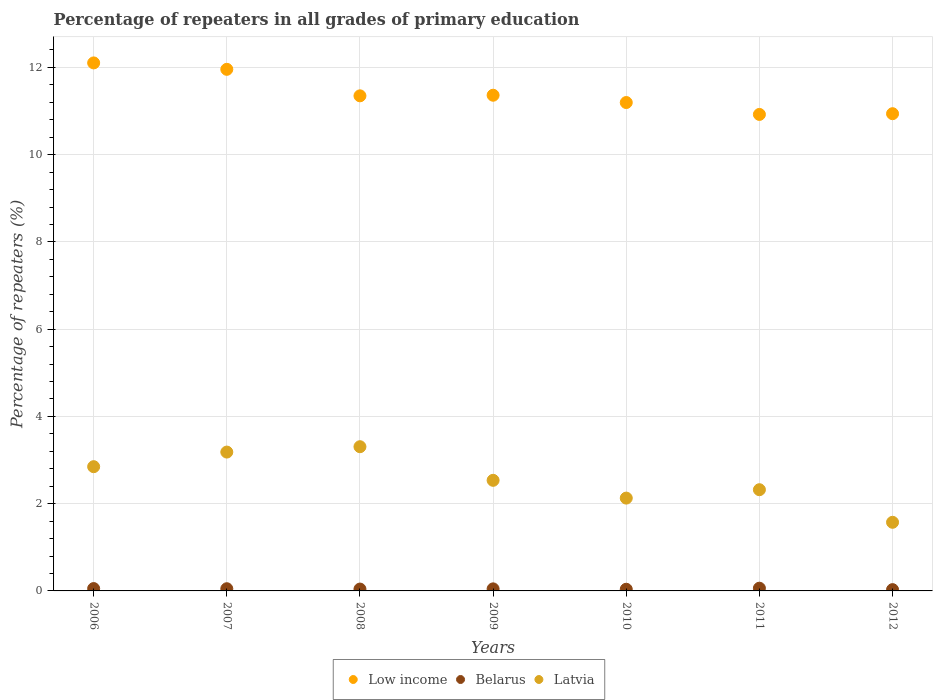Is the number of dotlines equal to the number of legend labels?
Keep it short and to the point. Yes. What is the percentage of repeaters in Belarus in 2011?
Provide a succinct answer. 0.06. Across all years, what is the maximum percentage of repeaters in Latvia?
Provide a succinct answer. 3.31. Across all years, what is the minimum percentage of repeaters in Latvia?
Give a very brief answer. 1.57. In which year was the percentage of repeaters in Low income maximum?
Your answer should be compact. 2006. What is the total percentage of repeaters in Low income in the graph?
Your response must be concise. 79.83. What is the difference between the percentage of repeaters in Low income in 2008 and that in 2011?
Make the answer very short. 0.43. What is the difference between the percentage of repeaters in Belarus in 2012 and the percentage of repeaters in Low income in 2010?
Offer a terse response. -11.17. What is the average percentage of repeaters in Low income per year?
Provide a short and direct response. 11.4. In the year 2007, what is the difference between the percentage of repeaters in Latvia and percentage of repeaters in Low income?
Your answer should be very brief. -8.77. What is the ratio of the percentage of repeaters in Low income in 2006 to that in 2008?
Your answer should be compact. 1.07. What is the difference between the highest and the second highest percentage of repeaters in Low income?
Provide a succinct answer. 0.15. What is the difference between the highest and the lowest percentage of repeaters in Latvia?
Ensure brevity in your answer.  1.73. Is it the case that in every year, the sum of the percentage of repeaters in Low income and percentage of repeaters in Belarus  is greater than the percentage of repeaters in Latvia?
Provide a short and direct response. Yes. Does the percentage of repeaters in Latvia monotonically increase over the years?
Make the answer very short. No. How many dotlines are there?
Ensure brevity in your answer.  3. How many years are there in the graph?
Your answer should be compact. 7. What is the difference between two consecutive major ticks on the Y-axis?
Ensure brevity in your answer.  2. Are the values on the major ticks of Y-axis written in scientific E-notation?
Provide a succinct answer. No. Does the graph contain any zero values?
Your answer should be compact. No. Does the graph contain grids?
Give a very brief answer. Yes. Where does the legend appear in the graph?
Your response must be concise. Bottom center. How many legend labels are there?
Provide a succinct answer. 3. What is the title of the graph?
Your answer should be compact. Percentage of repeaters in all grades of primary education. What is the label or title of the X-axis?
Offer a very short reply. Years. What is the label or title of the Y-axis?
Offer a terse response. Percentage of repeaters (%). What is the Percentage of repeaters (%) of Low income in 2006?
Give a very brief answer. 12.1. What is the Percentage of repeaters (%) in Belarus in 2006?
Provide a short and direct response. 0.05. What is the Percentage of repeaters (%) of Latvia in 2006?
Ensure brevity in your answer.  2.85. What is the Percentage of repeaters (%) in Low income in 2007?
Keep it short and to the point. 11.96. What is the Percentage of repeaters (%) in Belarus in 2007?
Give a very brief answer. 0.05. What is the Percentage of repeaters (%) in Latvia in 2007?
Provide a succinct answer. 3.18. What is the Percentage of repeaters (%) in Low income in 2008?
Offer a very short reply. 11.35. What is the Percentage of repeaters (%) in Belarus in 2008?
Make the answer very short. 0.04. What is the Percentage of repeaters (%) of Latvia in 2008?
Give a very brief answer. 3.31. What is the Percentage of repeaters (%) in Low income in 2009?
Your answer should be very brief. 11.36. What is the Percentage of repeaters (%) in Belarus in 2009?
Offer a terse response. 0.05. What is the Percentage of repeaters (%) of Latvia in 2009?
Your response must be concise. 2.54. What is the Percentage of repeaters (%) in Low income in 2010?
Your answer should be very brief. 11.19. What is the Percentage of repeaters (%) of Belarus in 2010?
Ensure brevity in your answer.  0.04. What is the Percentage of repeaters (%) of Latvia in 2010?
Provide a succinct answer. 2.13. What is the Percentage of repeaters (%) in Low income in 2011?
Provide a short and direct response. 10.92. What is the Percentage of repeaters (%) in Belarus in 2011?
Your answer should be compact. 0.06. What is the Percentage of repeaters (%) of Latvia in 2011?
Offer a very short reply. 2.32. What is the Percentage of repeaters (%) in Low income in 2012?
Provide a succinct answer. 10.94. What is the Percentage of repeaters (%) in Belarus in 2012?
Provide a short and direct response. 0.03. What is the Percentage of repeaters (%) in Latvia in 2012?
Provide a succinct answer. 1.57. Across all years, what is the maximum Percentage of repeaters (%) of Low income?
Keep it short and to the point. 12.1. Across all years, what is the maximum Percentage of repeaters (%) in Belarus?
Make the answer very short. 0.06. Across all years, what is the maximum Percentage of repeaters (%) of Latvia?
Offer a very short reply. 3.31. Across all years, what is the minimum Percentage of repeaters (%) in Low income?
Give a very brief answer. 10.92. Across all years, what is the minimum Percentage of repeaters (%) in Belarus?
Offer a very short reply. 0.03. Across all years, what is the minimum Percentage of repeaters (%) in Latvia?
Your answer should be compact. 1.57. What is the total Percentage of repeaters (%) in Low income in the graph?
Give a very brief answer. 79.83. What is the total Percentage of repeaters (%) in Belarus in the graph?
Make the answer very short. 0.32. What is the total Percentage of repeaters (%) in Latvia in the graph?
Give a very brief answer. 17.89. What is the difference between the Percentage of repeaters (%) in Low income in 2006 and that in 2007?
Keep it short and to the point. 0.15. What is the difference between the Percentage of repeaters (%) in Belarus in 2006 and that in 2007?
Offer a very short reply. 0. What is the difference between the Percentage of repeaters (%) of Latvia in 2006 and that in 2007?
Keep it short and to the point. -0.33. What is the difference between the Percentage of repeaters (%) of Low income in 2006 and that in 2008?
Your answer should be compact. 0.75. What is the difference between the Percentage of repeaters (%) of Belarus in 2006 and that in 2008?
Offer a very short reply. 0.01. What is the difference between the Percentage of repeaters (%) in Latvia in 2006 and that in 2008?
Ensure brevity in your answer.  -0.46. What is the difference between the Percentage of repeaters (%) in Low income in 2006 and that in 2009?
Make the answer very short. 0.74. What is the difference between the Percentage of repeaters (%) of Belarus in 2006 and that in 2009?
Offer a very short reply. 0.01. What is the difference between the Percentage of repeaters (%) of Latvia in 2006 and that in 2009?
Make the answer very short. 0.31. What is the difference between the Percentage of repeaters (%) in Low income in 2006 and that in 2010?
Your answer should be very brief. 0.91. What is the difference between the Percentage of repeaters (%) of Belarus in 2006 and that in 2010?
Ensure brevity in your answer.  0.02. What is the difference between the Percentage of repeaters (%) of Latvia in 2006 and that in 2010?
Make the answer very short. 0.72. What is the difference between the Percentage of repeaters (%) in Low income in 2006 and that in 2011?
Provide a short and direct response. 1.18. What is the difference between the Percentage of repeaters (%) of Belarus in 2006 and that in 2011?
Your answer should be very brief. -0.01. What is the difference between the Percentage of repeaters (%) in Latvia in 2006 and that in 2011?
Your answer should be very brief. 0.53. What is the difference between the Percentage of repeaters (%) of Low income in 2006 and that in 2012?
Make the answer very short. 1.16. What is the difference between the Percentage of repeaters (%) in Belarus in 2006 and that in 2012?
Provide a succinct answer. 0.02. What is the difference between the Percentage of repeaters (%) in Latvia in 2006 and that in 2012?
Ensure brevity in your answer.  1.27. What is the difference between the Percentage of repeaters (%) in Low income in 2007 and that in 2008?
Offer a terse response. 0.61. What is the difference between the Percentage of repeaters (%) in Belarus in 2007 and that in 2008?
Make the answer very short. 0.01. What is the difference between the Percentage of repeaters (%) of Latvia in 2007 and that in 2008?
Make the answer very short. -0.12. What is the difference between the Percentage of repeaters (%) of Low income in 2007 and that in 2009?
Your answer should be compact. 0.59. What is the difference between the Percentage of repeaters (%) in Belarus in 2007 and that in 2009?
Your answer should be very brief. 0. What is the difference between the Percentage of repeaters (%) in Latvia in 2007 and that in 2009?
Provide a succinct answer. 0.65. What is the difference between the Percentage of repeaters (%) of Low income in 2007 and that in 2010?
Your answer should be compact. 0.76. What is the difference between the Percentage of repeaters (%) in Belarus in 2007 and that in 2010?
Make the answer very short. 0.01. What is the difference between the Percentage of repeaters (%) in Latvia in 2007 and that in 2010?
Ensure brevity in your answer.  1.05. What is the difference between the Percentage of repeaters (%) in Low income in 2007 and that in 2011?
Your answer should be very brief. 1.03. What is the difference between the Percentage of repeaters (%) of Belarus in 2007 and that in 2011?
Offer a very short reply. -0.01. What is the difference between the Percentage of repeaters (%) in Latvia in 2007 and that in 2011?
Offer a very short reply. 0.86. What is the difference between the Percentage of repeaters (%) in Low income in 2007 and that in 2012?
Your answer should be very brief. 1.02. What is the difference between the Percentage of repeaters (%) of Belarus in 2007 and that in 2012?
Your answer should be compact. 0.02. What is the difference between the Percentage of repeaters (%) of Latvia in 2007 and that in 2012?
Your answer should be very brief. 1.61. What is the difference between the Percentage of repeaters (%) in Low income in 2008 and that in 2009?
Your response must be concise. -0.01. What is the difference between the Percentage of repeaters (%) in Belarus in 2008 and that in 2009?
Give a very brief answer. -0. What is the difference between the Percentage of repeaters (%) in Latvia in 2008 and that in 2009?
Keep it short and to the point. 0.77. What is the difference between the Percentage of repeaters (%) of Low income in 2008 and that in 2010?
Offer a very short reply. 0.15. What is the difference between the Percentage of repeaters (%) in Belarus in 2008 and that in 2010?
Your answer should be very brief. 0. What is the difference between the Percentage of repeaters (%) of Latvia in 2008 and that in 2010?
Provide a succinct answer. 1.18. What is the difference between the Percentage of repeaters (%) of Low income in 2008 and that in 2011?
Keep it short and to the point. 0.43. What is the difference between the Percentage of repeaters (%) in Belarus in 2008 and that in 2011?
Your response must be concise. -0.02. What is the difference between the Percentage of repeaters (%) in Latvia in 2008 and that in 2011?
Keep it short and to the point. 0.99. What is the difference between the Percentage of repeaters (%) of Low income in 2008 and that in 2012?
Your answer should be compact. 0.41. What is the difference between the Percentage of repeaters (%) in Belarus in 2008 and that in 2012?
Your answer should be compact. 0.01. What is the difference between the Percentage of repeaters (%) of Latvia in 2008 and that in 2012?
Your response must be concise. 1.73. What is the difference between the Percentage of repeaters (%) in Low income in 2009 and that in 2010?
Keep it short and to the point. 0.17. What is the difference between the Percentage of repeaters (%) in Belarus in 2009 and that in 2010?
Offer a terse response. 0.01. What is the difference between the Percentage of repeaters (%) in Latvia in 2009 and that in 2010?
Offer a terse response. 0.41. What is the difference between the Percentage of repeaters (%) in Low income in 2009 and that in 2011?
Keep it short and to the point. 0.44. What is the difference between the Percentage of repeaters (%) of Belarus in 2009 and that in 2011?
Keep it short and to the point. -0.02. What is the difference between the Percentage of repeaters (%) in Latvia in 2009 and that in 2011?
Offer a very short reply. 0.22. What is the difference between the Percentage of repeaters (%) in Low income in 2009 and that in 2012?
Offer a very short reply. 0.42. What is the difference between the Percentage of repeaters (%) in Belarus in 2009 and that in 2012?
Keep it short and to the point. 0.02. What is the difference between the Percentage of repeaters (%) in Latvia in 2009 and that in 2012?
Your answer should be very brief. 0.96. What is the difference between the Percentage of repeaters (%) in Low income in 2010 and that in 2011?
Offer a terse response. 0.27. What is the difference between the Percentage of repeaters (%) in Belarus in 2010 and that in 2011?
Keep it short and to the point. -0.02. What is the difference between the Percentage of repeaters (%) of Latvia in 2010 and that in 2011?
Offer a very short reply. -0.19. What is the difference between the Percentage of repeaters (%) of Low income in 2010 and that in 2012?
Give a very brief answer. 0.26. What is the difference between the Percentage of repeaters (%) in Belarus in 2010 and that in 2012?
Provide a succinct answer. 0.01. What is the difference between the Percentage of repeaters (%) in Latvia in 2010 and that in 2012?
Your answer should be very brief. 0.55. What is the difference between the Percentage of repeaters (%) in Low income in 2011 and that in 2012?
Your answer should be very brief. -0.02. What is the difference between the Percentage of repeaters (%) of Belarus in 2011 and that in 2012?
Make the answer very short. 0.03. What is the difference between the Percentage of repeaters (%) of Latvia in 2011 and that in 2012?
Provide a succinct answer. 0.75. What is the difference between the Percentage of repeaters (%) in Low income in 2006 and the Percentage of repeaters (%) in Belarus in 2007?
Provide a short and direct response. 12.05. What is the difference between the Percentage of repeaters (%) of Low income in 2006 and the Percentage of repeaters (%) of Latvia in 2007?
Provide a short and direct response. 8.92. What is the difference between the Percentage of repeaters (%) of Belarus in 2006 and the Percentage of repeaters (%) of Latvia in 2007?
Give a very brief answer. -3.13. What is the difference between the Percentage of repeaters (%) in Low income in 2006 and the Percentage of repeaters (%) in Belarus in 2008?
Give a very brief answer. 12.06. What is the difference between the Percentage of repeaters (%) of Low income in 2006 and the Percentage of repeaters (%) of Latvia in 2008?
Offer a terse response. 8.8. What is the difference between the Percentage of repeaters (%) in Belarus in 2006 and the Percentage of repeaters (%) in Latvia in 2008?
Offer a terse response. -3.25. What is the difference between the Percentage of repeaters (%) of Low income in 2006 and the Percentage of repeaters (%) of Belarus in 2009?
Give a very brief answer. 12.06. What is the difference between the Percentage of repeaters (%) in Low income in 2006 and the Percentage of repeaters (%) in Latvia in 2009?
Ensure brevity in your answer.  9.57. What is the difference between the Percentage of repeaters (%) in Belarus in 2006 and the Percentage of repeaters (%) in Latvia in 2009?
Provide a short and direct response. -2.48. What is the difference between the Percentage of repeaters (%) in Low income in 2006 and the Percentage of repeaters (%) in Belarus in 2010?
Your answer should be compact. 12.06. What is the difference between the Percentage of repeaters (%) of Low income in 2006 and the Percentage of repeaters (%) of Latvia in 2010?
Provide a short and direct response. 9.98. What is the difference between the Percentage of repeaters (%) in Belarus in 2006 and the Percentage of repeaters (%) in Latvia in 2010?
Provide a succinct answer. -2.07. What is the difference between the Percentage of repeaters (%) in Low income in 2006 and the Percentage of repeaters (%) in Belarus in 2011?
Offer a terse response. 12.04. What is the difference between the Percentage of repeaters (%) of Low income in 2006 and the Percentage of repeaters (%) of Latvia in 2011?
Provide a short and direct response. 9.78. What is the difference between the Percentage of repeaters (%) in Belarus in 2006 and the Percentage of repeaters (%) in Latvia in 2011?
Your answer should be compact. -2.27. What is the difference between the Percentage of repeaters (%) in Low income in 2006 and the Percentage of repeaters (%) in Belarus in 2012?
Keep it short and to the point. 12.07. What is the difference between the Percentage of repeaters (%) in Low income in 2006 and the Percentage of repeaters (%) in Latvia in 2012?
Make the answer very short. 10.53. What is the difference between the Percentage of repeaters (%) in Belarus in 2006 and the Percentage of repeaters (%) in Latvia in 2012?
Offer a very short reply. -1.52. What is the difference between the Percentage of repeaters (%) of Low income in 2007 and the Percentage of repeaters (%) of Belarus in 2008?
Make the answer very short. 11.91. What is the difference between the Percentage of repeaters (%) in Low income in 2007 and the Percentage of repeaters (%) in Latvia in 2008?
Provide a short and direct response. 8.65. What is the difference between the Percentage of repeaters (%) of Belarus in 2007 and the Percentage of repeaters (%) of Latvia in 2008?
Your answer should be compact. -3.26. What is the difference between the Percentage of repeaters (%) in Low income in 2007 and the Percentage of repeaters (%) in Belarus in 2009?
Your answer should be very brief. 11.91. What is the difference between the Percentage of repeaters (%) in Low income in 2007 and the Percentage of repeaters (%) in Latvia in 2009?
Make the answer very short. 9.42. What is the difference between the Percentage of repeaters (%) in Belarus in 2007 and the Percentage of repeaters (%) in Latvia in 2009?
Give a very brief answer. -2.48. What is the difference between the Percentage of repeaters (%) of Low income in 2007 and the Percentage of repeaters (%) of Belarus in 2010?
Ensure brevity in your answer.  11.92. What is the difference between the Percentage of repeaters (%) of Low income in 2007 and the Percentage of repeaters (%) of Latvia in 2010?
Offer a terse response. 9.83. What is the difference between the Percentage of repeaters (%) of Belarus in 2007 and the Percentage of repeaters (%) of Latvia in 2010?
Your answer should be very brief. -2.08. What is the difference between the Percentage of repeaters (%) of Low income in 2007 and the Percentage of repeaters (%) of Belarus in 2011?
Offer a terse response. 11.89. What is the difference between the Percentage of repeaters (%) in Low income in 2007 and the Percentage of repeaters (%) in Latvia in 2011?
Ensure brevity in your answer.  9.64. What is the difference between the Percentage of repeaters (%) of Belarus in 2007 and the Percentage of repeaters (%) of Latvia in 2011?
Provide a short and direct response. -2.27. What is the difference between the Percentage of repeaters (%) in Low income in 2007 and the Percentage of repeaters (%) in Belarus in 2012?
Make the answer very short. 11.93. What is the difference between the Percentage of repeaters (%) of Low income in 2007 and the Percentage of repeaters (%) of Latvia in 2012?
Offer a very short reply. 10.38. What is the difference between the Percentage of repeaters (%) in Belarus in 2007 and the Percentage of repeaters (%) in Latvia in 2012?
Your response must be concise. -1.52. What is the difference between the Percentage of repeaters (%) of Low income in 2008 and the Percentage of repeaters (%) of Belarus in 2009?
Offer a terse response. 11.3. What is the difference between the Percentage of repeaters (%) of Low income in 2008 and the Percentage of repeaters (%) of Latvia in 2009?
Offer a very short reply. 8.81. What is the difference between the Percentage of repeaters (%) in Belarus in 2008 and the Percentage of repeaters (%) in Latvia in 2009?
Your response must be concise. -2.49. What is the difference between the Percentage of repeaters (%) of Low income in 2008 and the Percentage of repeaters (%) of Belarus in 2010?
Offer a very short reply. 11.31. What is the difference between the Percentage of repeaters (%) in Low income in 2008 and the Percentage of repeaters (%) in Latvia in 2010?
Provide a short and direct response. 9.22. What is the difference between the Percentage of repeaters (%) of Belarus in 2008 and the Percentage of repeaters (%) of Latvia in 2010?
Make the answer very short. -2.09. What is the difference between the Percentage of repeaters (%) of Low income in 2008 and the Percentage of repeaters (%) of Belarus in 2011?
Make the answer very short. 11.29. What is the difference between the Percentage of repeaters (%) in Low income in 2008 and the Percentage of repeaters (%) in Latvia in 2011?
Keep it short and to the point. 9.03. What is the difference between the Percentage of repeaters (%) of Belarus in 2008 and the Percentage of repeaters (%) of Latvia in 2011?
Ensure brevity in your answer.  -2.28. What is the difference between the Percentage of repeaters (%) of Low income in 2008 and the Percentage of repeaters (%) of Belarus in 2012?
Your response must be concise. 11.32. What is the difference between the Percentage of repeaters (%) in Low income in 2008 and the Percentage of repeaters (%) in Latvia in 2012?
Your answer should be compact. 9.78. What is the difference between the Percentage of repeaters (%) of Belarus in 2008 and the Percentage of repeaters (%) of Latvia in 2012?
Offer a very short reply. -1.53. What is the difference between the Percentage of repeaters (%) in Low income in 2009 and the Percentage of repeaters (%) in Belarus in 2010?
Offer a terse response. 11.32. What is the difference between the Percentage of repeaters (%) of Low income in 2009 and the Percentage of repeaters (%) of Latvia in 2010?
Keep it short and to the point. 9.23. What is the difference between the Percentage of repeaters (%) of Belarus in 2009 and the Percentage of repeaters (%) of Latvia in 2010?
Offer a terse response. -2.08. What is the difference between the Percentage of repeaters (%) of Low income in 2009 and the Percentage of repeaters (%) of Belarus in 2011?
Provide a succinct answer. 11.3. What is the difference between the Percentage of repeaters (%) of Low income in 2009 and the Percentage of repeaters (%) of Latvia in 2011?
Provide a succinct answer. 9.04. What is the difference between the Percentage of repeaters (%) of Belarus in 2009 and the Percentage of repeaters (%) of Latvia in 2011?
Offer a very short reply. -2.27. What is the difference between the Percentage of repeaters (%) of Low income in 2009 and the Percentage of repeaters (%) of Belarus in 2012?
Your response must be concise. 11.33. What is the difference between the Percentage of repeaters (%) in Low income in 2009 and the Percentage of repeaters (%) in Latvia in 2012?
Provide a succinct answer. 9.79. What is the difference between the Percentage of repeaters (%) in Belarus in 2009 and the Percentage of repeaters (%) in Latvia in 2012?
Provide a short and direct response. -1.53. What is the difference between the Percentage of repeaters (%) of Low income in 2010 and the Percentage of repeaters (%) of Belarus in 2011?
Provide a short and direct response. 11.13. What is the difference between the Percentage of repeaters (%) in Low income in 2010 and the Percentage of repeaters (%) in Latvia in 2011?
Your response must be concise. 8.88. What is the difference between the Percentage of repeaters (%) in Belarus in 2010 and the Percentage of repeaters (%) in Latvia in 2011?
Your answer should be very brief. -2.28. What is the difference between the Percentage of repeaters (%) of Low income in 2010 and the Percentage of repeaters (%) of Belarus in 2012?
Give a very brief answer. 11.17. What is the difference between the Percentage of repeaters (%) of Low income in 2010 and the Percentage of repeaters (%) of Latvia in 2012?
Offer a terse response. 9.62. What is the difference between the Percentage of repeaters (%) of Belarus in 2010 and the Percentage of repeaters (%) of Latvia in 2012?
Give a very brief answer. -1.53. What is the difference between the Percentage of repeaters (%) of Low income in 2011 and the Percentage of repeaters (%) of Belarus in 2012?
Your answer should be compact. 10.89. What is the difference between the Percentage of repeaters (%) of Low income in 2011 and the Percentage of repeaters (%) of Latvia in 2012?
Ensure brevity in your answer.  9.35. What is the difference between the Percentage of repeaters (%) in Belarus in 2011 and the Percentage of repeaters (%) in Latvia in 2012?
Your response must be concise. -1.51. What is the average Percentage of repeaters (%) of Low income per year?
Ensure brevity in your answer.  11.4. What is the average Percentage of repeaters (%) in Belarus per year?
Your response must be concise. 0.05. What is the average Percentage of repeaters (%) in Latvia per year?
Your response must be concise. 2.56. In the year 2006, what is the difference between the Percentage of repeaters (%) in Low income and Percentage of repeaters (%) in Belarus?
Make the answer very short. 12.05. In the year 2006, what is the difference between the Percentage of repeaters (%) in Low income and Percentage of repeaters (%) in Latvia?
Offer a very short reply. 9.26. In the year 2006, what is the difference between the Percentage of repeaters (%) in Belarus and Percentage of repeaters (%) in Latvia?
Provide a succinct answer. -2.79. In the year 2007, what is the difference between the Percentage of repeaters (%) of Low income and Percentage of repeaters (%) of Belarus?
Make the answer very short. 11.91. In the year 2007, what is the difference between the Percentage of repeaters (%) of Low income and Percentage of repeaters (%) of Latvia?
Give a very brief answer. 8.77. In the year 2007, what is the difference between the Percentage of repeaters (%) in Belarus and Percentage of repeaters (%) in Latvia?
Make the answer very short. -3.13. In the year 2008, what is the difference between the Percentage of repeaters (%) in Low income and Percentage of repeaters (%) in Belarus?
Your answer should be compact. 11.31. In the year 2008, what is the difference between the Percentage of repeaters (%) in Low income and Percentage of repeaters (%) in Latvia?
Your answer should be very brief. 8.04. In the year 2008, what is the difference between the Percentage of repeaters (%) in Belarus and Percentage of repeaters (%) in Latvia?
Keep it short and to the point. -3.26. In the year 2009, what is the difference between the Percentage of repeaters (%) of Low income and Percentage of repeaters (%) of Belarus?
Offer a very short reply. 11.32. In the year 2009, what is the difference between the Percentage of repeaters (%) of Low income and Percentage of repeaters (%) of Latvia?
Your answer should be compact. 8.83. In the year 2009, what is the difference between the Percentage of repeaters (%) of Belarus and Percentage of repeaters (%) of Latvia?
Your answer should be very brief. -2.49. In the year 2010, what is the difference between the Percentage of repeaters (%) of Low income and Percentage of repeaters (%) of Belarus?
Provide a succinct answer. 11.16. In the year 2010, what is the difference between the Percentage of repeaters (%) of Low income and Percentage of repeaters (%) of Latvia?
Your response must be concise. 9.07. In the year 2010, what is the difference between the Percentage of repeaters (%) in Belarus and Percentage of repeaters (%) in Latvia?
Keep it short and to the point. -2.09. In the year 2011, what is the difference between the Percentage of repeaters (%) in Low income and Percentage of repeaters (%) in Belarus?
Offer a very short reply. 10.86. In the year 2011, what is the difference between the Percentage of repeaters (%) in Low income and Percentage of repeaters (%) in Latvia?
Make the answer very short. 8.6. In the year 2011, what is the difference between the Percentage of repeaters (%) in Belarus and Percentage of repeaters (%) in Latvia?
Your answer should be compact. -2.26. In the year 2012, what is the difference between the Percentage of repeaters (%) in Low income and Percentage of repeaters (%) in Belarus?
Keep it short and to the point. 10.91. In the year 2012, what is the difference between the Percentage of repeaters (%) of Low income and Percentage of repeaters (%) of Latvia?
Make the answer very short. 9.37. In the year 2012, what is the difference between the Percentage of repeaters (%) in Belarus and Percentage of repeaters (%) in Latvia?
Provide a short and direct response. -1.54. What is the ratio of the Percentage of repeaters (%) in Low income in 2006 to that in 2007?
Give a very brief answer. 1.01. What is the ratio of the Percentage of repeaters (%) of Belarus in 2006 to that in 2007?
Your response must be concise. 1.07. What is the ratio of the Percentage of repeaters (%) in Latvia in 2006 to that in 2007?
Keep it short and to the point. 0.89. What is the ratio of the Percentage of repeaters (%) in Low income in 2006 to that in 2008?
Provide a short and direct response. 1.07. What is the ratio of the Percentage of repeaters (%) of Belarus in 2006 to that in 2008?
Ensure brevity in your answer.  1.27. What is the ratio of the Percentage of repeaters (%) of Latvia in 2006 to that in 2008?
Ensure brevity in your answer.  0.86. What is the ratio of the Percentage of repeaters (%) in Low income in 2006 to that in 2009?
Your answer should be very brief. 1.07. What is the ratio of the Percentage of repeaters (%) in Belarus in 2006 to that in 2009?
Give a very brief answer. 1.14. What is the ratio of the Percentage of repeaters (%) in Latvia in 2006 to that in 2009?
Make the answer very short. 1.12. What is the ratio of the Percentage of repeaters (%) in Low income in 2006 to that in 2010?
Make the answer very short. 1.08. What is the ratio of the Percentage of repeaters (%) in Belarus in 2006 to that in 2010?
Make the answer very short. 1.41. What is the ratio of the Percentage of repeaters (%) in Latvia in 2006 to that in 2010?
Make the answer very short. 1.34. What is the ratio of the Percentage of repeaters (%) in Low income in 2006 to that in 2011?
Provide a short and direct response. 1.11. What is the ratio of the Percentage of repeaters (%) of Belarus in 2006 to that in 2011?
Your response must be concise. 0.86. What is the ratio of the Percentage of repeaters (%) of Latvia in 2006 to that in 2011?
Your answer should be compact. 1.23. What is the ratio of the Percentage of repeaters (%) in Low income in 2006 to that in 2012?
Your answer should be compact. 1.11. What is the ratio of the Percentage of repeaters (%) of Belarus in 2006 to that in 2012?
Offer a terse response. 1.82. What is the ratio of the Percentage of repeaters (%) of Latvia in 2006 to that in 2012?
Your response must be concise. 1.81. What is the ratio of the Percentage of repeaters (%) of Low income in 2007 to that in 2008?
Your response must be concise. 1.05. What is the ratio of the Percentage of repeaters (%) in Belarus in 2007 to that in 2008?
Make the answer very short. 1.18. What is the ratio of the Percentage of repeaters (%) of Latvia in 2007 to that in 2008?
Offer a terse response. 0.96. What is the ratio of the Percentage of repeaters (%) in Low income in 2007 to that in 2009?
Make the answer very short. 1.05. What is the ratio of the Percentage of repeaters (%) in Belarus in 2007 to that in 2009?
Offer a terse response. 1.07. What is the ratio of the Percentage of repeaters (%) in Latvia in 2007 to that in 2009?
Your answer should be compact. 1.26. What is the ratio of the Percentage of repeaters (%) in Low income in 2007 to that in 2010?
Offer a very short reply. 1.07. What is the ratio of the Percentage of repeaters (%) in Belarus in 2007 to that in 2010?
Your answer should be compact. 1.31. What is the ratio of the Percentage of repeaters (%) in Latvia in 2007 to that in 2010?
Keep it short and to the point. 1.5. What is the ratio of the Percentage of repeaters (%) of Low income in 2007 to that in 2011?
Ensure brevity in your answer.  1.09. What is the ratio of the Percentage of repeaters (%) of Belarus in 2007 to that in 2011?
Your answer should be very brief. 0.81. What is the ratio of the Percentage of repeaters (%) in Latvia in 2007 to that in 2011?
Give a very brief answer. 1.37. What is the ratio of the Percentage of repeaters (%) of Low income in 2007 to that in 2012?
Your answer should be very brief. 1.09. What is the ratio of the Percentage of repeaters (%) in Belarus in 2007 to that in 2012?
Give a very brief answer. 1.7. What is the ratio of the Percentage of repeaters (%) in Latvia in 2007 to that in 2012?
Provide a succinct answer. 2.02. What is the ratio of the Percentage of repeaters (%) of Low income in 2008 to that in 2009?
Give a very brief answer. 1. What is the ratio of the Percentage of repeaters (%) in Belarus in 2008 to that in 2009?
Your answer should be compact. 0.9. What is the ratio of the Percentage of repeaters (%) in Latvia in 2008 to that in 2009?
Offer a very short reply. 1.3. What is the ratio of the Percentage of repeaters (%) of Low income in 2008 to that in 2010?
Your response must be concise. 1.01. What is the ratio of the Percentage of repeaters (%) of Belarus in 2008 to that in 2010?
Offer a terse response. 1.11. What is the ratio of the Percentage of repeaters (%) of Latvia in 2008 to that in 2010?
Provide a short and direct response. 1.55. What is the ratio of the Percentage of repeaters (%) of Low income in 2008 to that in 2011?
Provide a succinct answer. 1.04. What is the ratio of the Percentage of repeaters (%) in Belarus in 2008 to that in 2011?
Give a very brief answer. 0.68. What is the ratio of the Percentage of repeaters (%) of Latvia in 2008 to that in 2011?
Your answer should be very brief. 1.43. What is the ratio of the Percentage of repeaters (%) of Low income in 2008 to that in 2012?
Your answer should be very brief. 1.04. What is the ratio of the Percentage of repeaters (%) in Belarus in 2008 to that in 2012?
Provide a succinct answer. 1.44. What is the ratio of the Percentage of repeaters (%) of Latvia in 2008 to that in 2012?
Your answer should be very brief. 2.1. What is the ratio of the Percentage of repeaters (%) in Belarus in 2009 to that in 2010?
Make the answer very short. 1.23. What is the ratio of the Percentage of repeaters (%) in Latvia in 2009 to that in 2010?
Give a very brief answer. 1.19. What is the ratio of the Percentage of repeaters (%) of Low income in 2009 to that in 2011?
Offer a very short reply. 1.04. What is the ratio of the Percentage of repeaters (%) of Belarus in 2009 to that in 2011?
Provide a short and direct response. 0.76. What is the ratio of the Percentage of repeaters (%) in Latvia in 2009 to that in 2011?
Ensure brevity in your answer.  1.09. What is the ratio of the Percentage of repeaters (%) of Low income in 2009 to that in 2012?
Give a very brief answer. 1.04. What is the ratio of the Percentage of repeaters (%) of Belarus in 2009 to that in 2012?
Keep it short and to the point. 1.6. What is the ratio of the Percentage of repeaters (%) of Latvia in 2009 to that in 2012?
Keep it short and to the point. 1.61. What is the ratio of the Percentage of repeaters (%) in Belarus in 2010 to that in 2011?
Ensure brevity in your answer.  0.61. What is the ratio of the Percentage of repeaters (%) in Latvia in 2010 to that in 2011?
Ensure brevity in your answer.  0.92. What is the ratio of the Percentage of repeaters (%) in Low income in 2010 to that in 2012?
Your answer should be compact. 1.02. What is the ratio of the Percentage of repeaters (%) in Belarus in 2010 to that in 2012?
Provide a succinct answer. 1.3. What is the ratio of the Percentage of repeaters (%) in Latvia in 2010 to that in 2012?
Your answer should be compact. 1.35. What is the ratio of the Percentage of repeaters (%) of Belarus in 2011 to that in 2012?
Make the answer very short. 2.11. What is the ratio of the Percentage of repeaters (%) of Latvia in 2011 to that in 2012?
Your response must be concise. 1.47. What is the difference between the highest and the second highest Percentage of repeaters (%) in Low income?
Provide a short and direct response. 0.15. What is the difference between the highest and the second highest Percentage of repeaters (%) of Belarus?
Your answer should be very brief. 0.01. What is the difference between the highest and the second highest Percentage of repeaters (%) of Latvia?
Ensure brevity in your answer.  0.12. What is the difference between the highest and the lowest Percentage of repeaters (%) of Low income?
Offer a very short reply. 1.18. What is the difference between the highest and the lowest Percentage of repeaters (%) in Belarus?
Your answer should be compact. 0.03. What is the difference between the highest and the lowest Percentage of repeaters (%) of Latvia?
Offer a very short reply. 1.73. 